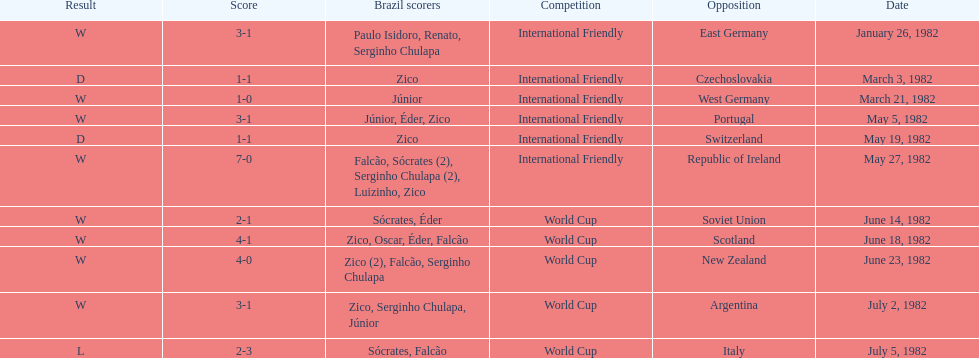How many times did brazil play west germany during the 1982 season? 1. 